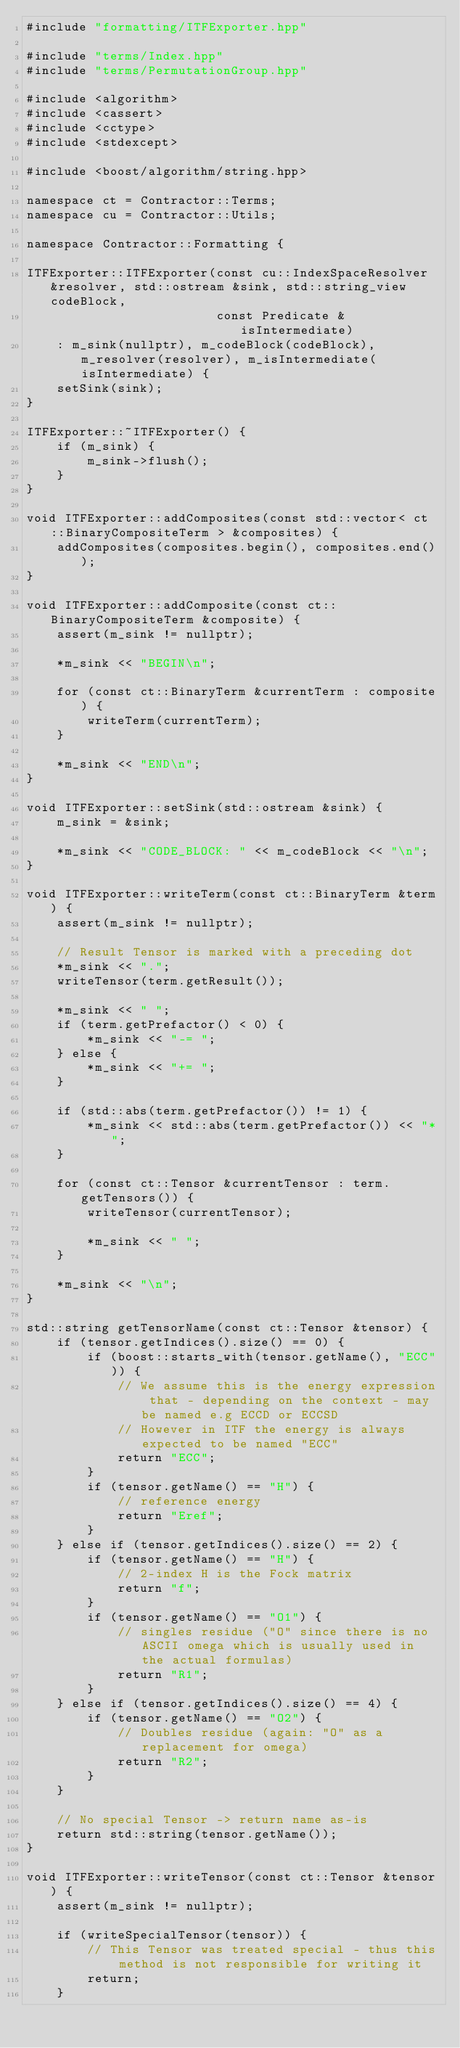Convert code to text. <code><loc_0><loc_0><loc_500><loc_500><_C++_>#include "formatting/ITFExporter.hpp"

#include "terms/Index.hpp"
#include "terms/PermutationGroup.hpp"

#include <algorithm>
#include <cassert>
#include <cctype>
#include <stdexcept>

#include <boost/algorithm/string.hpp>

namespace ct = Contractor::Terms;
namespace cu = Contractor::Utils;

namespace Contractor::Formatting {

ITFExporter::ITFExporter(const cu::IndexSpaceResolver &resolver, std::ostream &sink, std::string_view codeBlock,
						 const Predicate &isIntermediate)
	: m_sink(nullptr), m_codeBlock(codeBlock), m_resolver(resolver), m_isIntermediate(isIntermediate) {
	setSink(sink);
}

ITFExporter::~ITFExporter() {
	if (m_sink) {
		m_sink->flush();
	}
}

void ITFExporter::addComposites(const std::vector< ct::BinaryCompositeTerm > &composites) {
	addComposites(composites.begin(), composites.end());
}

void ITFExporter::addComposite(const ct::BinaryCompositeTerm &composite) {
	assert(m_sink != nullptr);

	*m_sink << "BEGIN\n";

	for (const ct::BinaryTerm &currentTerm : composite) {
		writeTerm(currentTerm);
	}

	*m_sink << "END\n";
}

void ITFExporter::setSink(std::ostream &sink) {
	m_sink = &sink;

	*m_sink << "CODE_BLOCK: " << m_codeBlock << "\n";
}

void ITFExporter::writeTerm(const ct::BinaryTerm &term) {
	assert(m_sink != nullptr);

	// Result Tensor is marked with a preceding dot
	*m_sink << ".";
	writeTensor(term.getResult());

	*m_sink << " ";
	if (term.getPrefactor() < 0) {
		*m_sink << "-= ";
	} else {
		*m_sink << "+= ";
	}

	if (std::abs(term.getPrefactor()) != 1) {
		*m_sink << std::abs(term.getPrefactor()) << "*";
	}

	for (const ct::Tensor &currentTensor : term.getTensors()) {
		writeTensor(currentTensor);

		*m_sink << " ";
	}

	*m_sink << "\n";
}

std::string getTensorName(const ct::Tensor &tensor) {
	if (tensor.getIndices().size() == 0) {
		if (boost::starts_with(tensor.getName(), "ECC")) {
			// We assume this is the energy expression that - depending on the context - may be named e.g ECCD or ECCSD
			// However in ITF the energy is always expected to be named "ECC"
			return "ECC";
		}
		if (tensor.getName() == "H") {
			// reference energy
			return "Eref";
		}
	} else if (tensor.getIndices().size() == 2) {
		if (tensor.getName() == "H") {
			// 2-index H is the Fock matrix
			return "f";
		}
		if (tensor.getName() == "O1") {
			// singles residue ("O" since there is no ASCII omega which is usually used in the actual formulas)
			return "R1";
		}
	} else if (tensor.getIndices().size() == 4) {
		if (tensor.getName() == "O2") {
			// Doubles residue (again: "O" as a replacement for omega)
			return "R2";
		}
	}

	// No special Tensor -> return name as-is
	return std::string(tensor.getName());
}

void ITFExporter::writeTensor(const ct::Tensor &tensor) {
	assert(m_sink != nullptr);

	if (writeSpecialTensor(tensor)) {
		// This Tensor was treated special - thus this method is not responsible for writing it
		return;
	}
</code> 